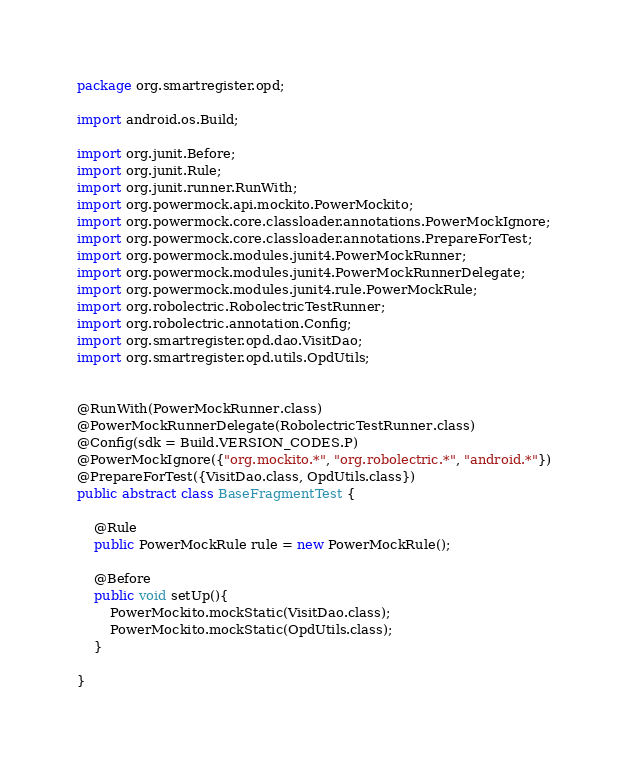Convert code to text. <code><loc_0><loc_0><loc_500><loc_500><_Java_>package org.smartregister.opd;

import android.os.Build;

import org.junit.Before;
import org.junit.Rule;
import org.junit.runner.RunWith;
import org.powermock.api.mockito.PowerMockito;
import org.powermock.core.classloader.annotations.PowerMockIgnore;
import org.powermock.core.classloader.annotations.PrepareForTest;
import org.powermock.modules.junit4.PowerMockRunner;
import org.powermock.modules.junit4.PowerMockRunnerDelegate;
import org.powermock.modules.junit4.rule.PowerMockRule;
import org.robolectric.RobolectricTestRunner;
import org.robolectric.annotation.Config;
import org.smartregister.opd.dao.VisitDao;
import org.smartregister.opd.utils.OpdUtils;


@RunWith(PowerMockRunner.class)
@PowerMockRunnerDelegate(RobolectricTestRunner.class)
@Config(sdk = Build.VERSION_CODES.P)
@PowerMockIgnore({"org.mockito.*", "org.robolectric.*", "android.*"})
@PrepareForTest({VisitDao.class, OpdUtils.class})
public abstract class BaseFragmentTest {

    @Rule
    public PowerMockRule rule = new PowerMockRule();
    
    @Before
    public void setUp(){
        PowerMockito.mockStatic(VisitDao.class);
        PowerMockito.mockStatic(OpdUtils.class);
    }

}
</code> 